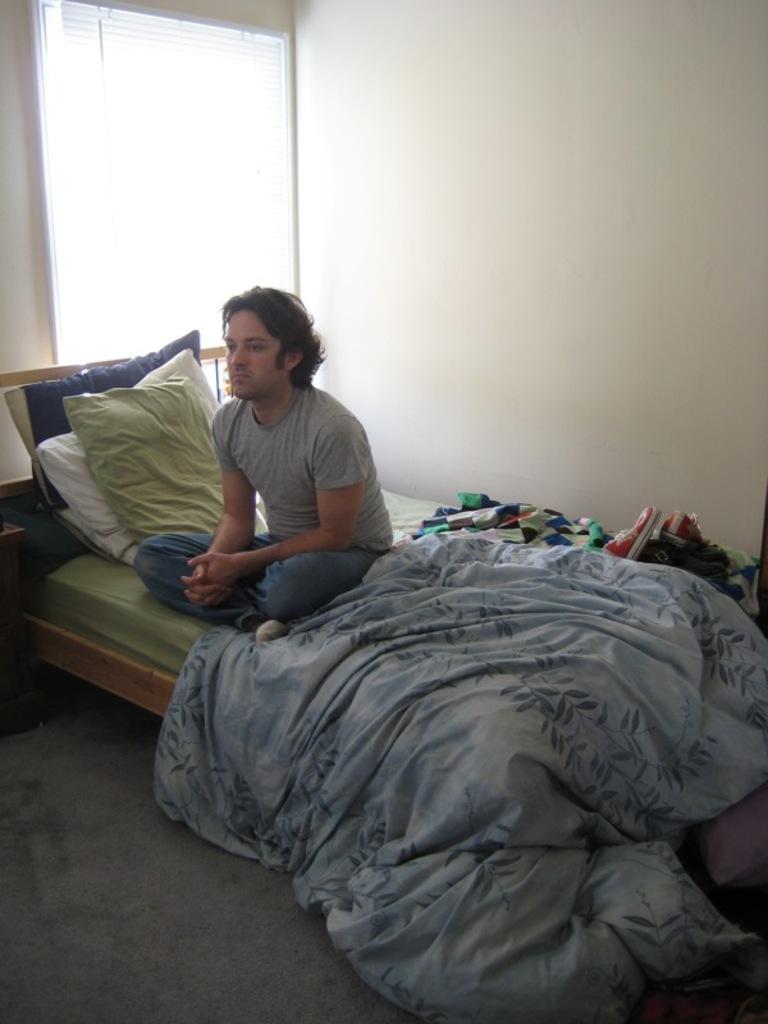How would you summarize this image in a sentence or two? In this image there is a person sitting on the bed, on the bed there are pillows, blanket, shoes and other objects. In the background there is a wall and a blind window. 